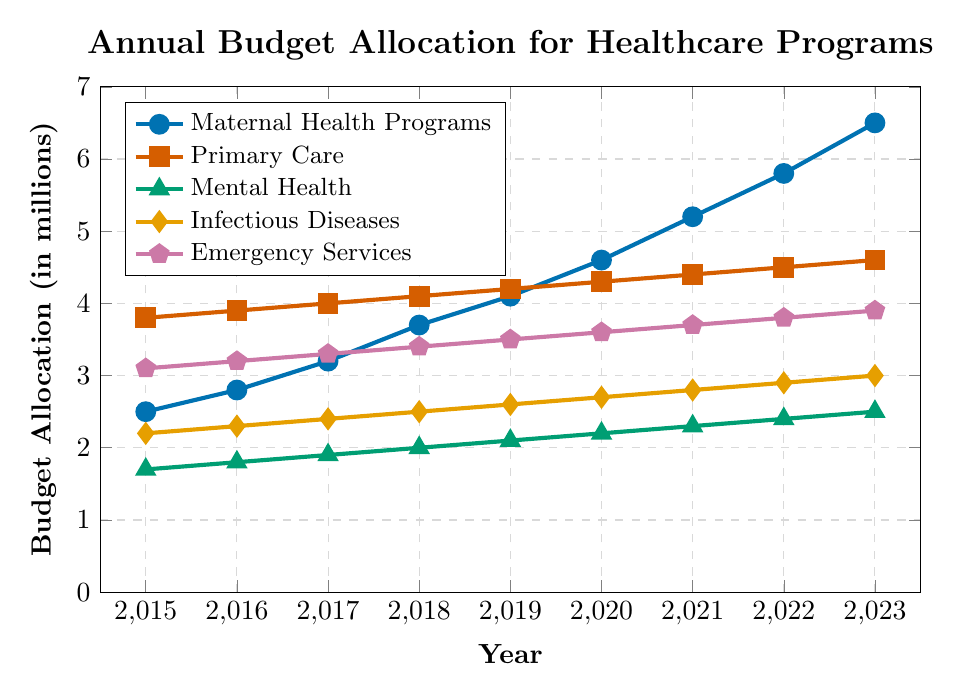What is the budget allocation for Maternal Health Programs in 2023? The chart shows the budget figures for each year, and for Maternal Health Programs in 2023, the value is above the 6 on the y-axis.
Answer: 6.5 million How does the budget allocation for Primary Care in 2023 compare to that for Infectious Diseases in the same year? Find the points on the y-axis for both Primary Care and Infectious Diseases in 2023. Primary Care is at 4.6 million and Infectious Diseases is at 3.0 million.
Answer: Primary Care is higher by 1.6 million Which healthcare initiative saw the most significant increase in its budget allocation from 2015 to 2023? Evaluate the changes in budget allocation by subtracting the 2015 values from the 2023 values for each initiative. Maternal Health Programs increased from 2.5 to 6.5, Primary Care from 3.8 to 4.6, Mental Health from 1.7 to 2.5, Infectious Diseases from 2.2 to 3.0, and Emergency Services from 3.1 to 3.9. Maternal Health Programs had the largest increase (6.5 - 2.5 = 4.0).
Answer: Maternal Health Programs What is the total budget allocated for all healthcare initiatives in 2020? Sum the individual values for each initiative in 2020: 4.6 + 4.3 + 2.2 + 2.7 + 3.6 = 17.4.
Answer: 17.4 million Are there any years in which the budget allocation for Emergency Services remained the same? Examine the trend line for Emergency Services represented by the pentagon marks. Notice that the budget allocation for Emergency Services increases consistently each year.
Answer: No Which healthcare initiative had the smallest budget allocation in 2017? Compare the y-axis values for each initiative in 2017: Maternal Health Programs (3.2), Primary Care (4.0), Mental Health (1.9), Infectious Diseases (2.4), Emergency Services (3.3). The smallest value is for Mental Health at 1.9.
Answer: Mental Health How much did the budget for Mental Health increase from 2015 to 2023? Subtract the 2015 value from the 2023 value for Mental Health: 2.5 - 1.7 = 0.8.
Answer: 0.8 million What is the average annual budget allocation for Maternal Health Programs from 2015 to 2023? Sum the budget allocations for each year from 2015 to 2023 and divide by the number of years: (2.5 + 2.8 + 3.2 + 3.7 + 4.1 + 4.6 + 5.2 + 5.8 + 6.5) / 9 = 38.4 / 9 = 4.27 (approximately).
Answer: 4.27 million In which year did Maternal Health Programs' budget surpass the 4 million mark? Look for when the y-axis value for Maternal Health Programs exceeds 4.0. This first occurs in 2019.
Answer: 2019 